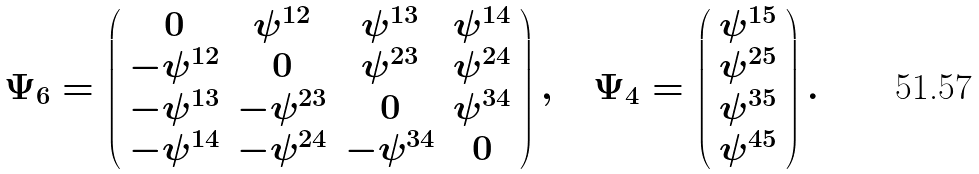<formula> <loc_0><loc_0><loc_500><loc_500>\Psi _ { 6 } = \left ( \begin{array} { c c c c } 0 & \psi ^ { 1 2 } & \psi ^ { 1 3 } & \psi ^ { 1 4 } \\ - \psi ^ { 1 2 } & 0 & \psi ^ { 2 3 } & \psi ^ { 2 4 } \\ - \psi ^ { 1 3 } & - \psi ^ { 2 3 } & 0 & \psi ^ { 3 4 } \\ - \psi ^ { 1 4 } & - \psi ^ { 2 4 } & - \psi ^ { 3 4 } & 0 \end{array} \right ) , \quad \Psi _ { 4 } = \left ( \begin{array} { c } \psi ^ { 1 5 } \\ \psi ^ { 2 5 } \\ \psi ^ { 3 5 } \\ \psi ^ { 4 5 } \end{array} \right ) .</formula> 